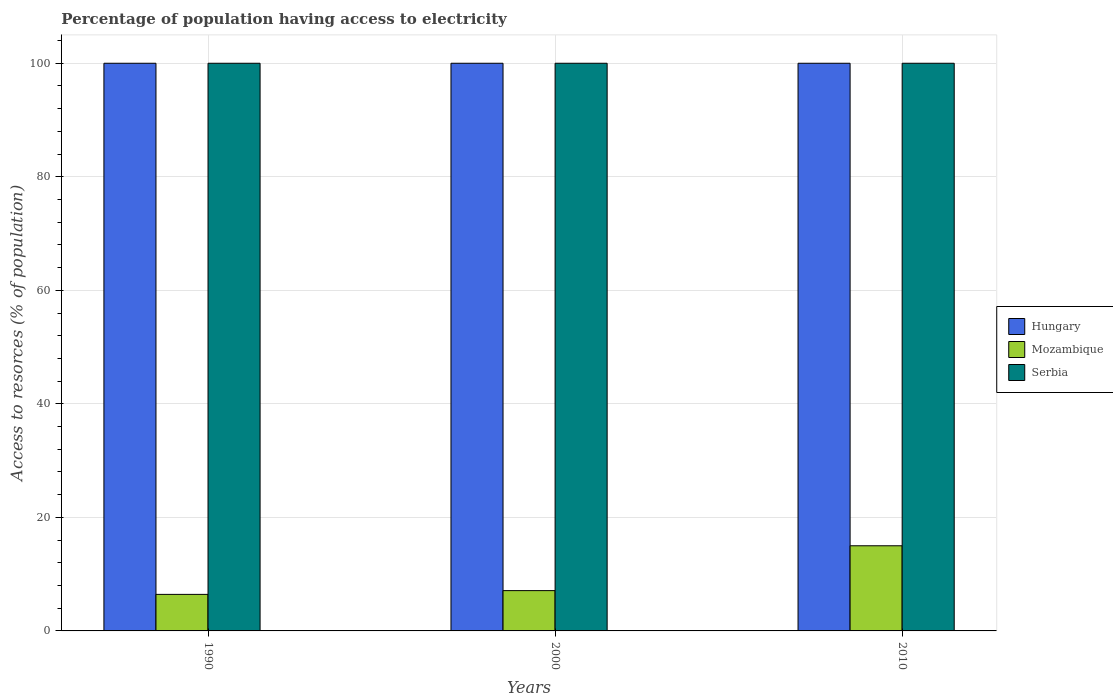Are the number of bars per tick equal to the number of legend labels?
Give a very brief answer. Yes. Are the number of bars on each tick of the X-axis equal?
Keep it short and to the point. Yes. How many bars are there on the 3rd tick from the left?
Make the answer very short. 3. Across all years, what is the maximum percentage of population having access to electricity in Hungary?
Give a very brief answer. 100. Across all years, what is the minimum percentage of population having access to electricity in Mozambique?
Your answer should be compact. 6.44. In which year was the percentage of population having access to electricity in Serbia maximum?
Keep it short and to the point. 1990. In which year was the percentage of population having access to electricity in Mozambique minimum?
Your response must be concise. 1990. What is the total percentage of population having access to electricity in Hungary in the graph?
Your response must be concise. 300. What is the difference between the percentage of population having access to electricity in Serbia in 2010 and the percentage of population having access to electricity in Hungary in 1990?
Your answer should be compact. 0. What is the average percentage of population having access to electricity in Mozambique per year?
Your response must be concise. 9.51. In the year 2000, what is the difference between the percentage of population having access to electricity in Hungary and percentage of population having access to electricity in Mozambique?
Provide a short and direct response. 92.9. In how many years, is the percentage of population having access to electricity in Serbia greater than 4 %?
Make the answer very short. 3. What is the ratio of the percentage of population having access to electricity in Hungary in 1990 to that in 2010?
Provide a succinct answer. 1. Is the difference between the percentage of population having access to electricity in Hungary in 2000 and 2010 greater than the difference between the percentage of population having access to electricity in Mozambique in 2000 and 2010?
Keep it short and to the point. Yes. What is the difference between the highest and the second highest percentage of population having access to electricity in Serbia?
Your answer should be compact. 0. What is the difference between the highest and the lowest percentage of population having access to electricity in Serbia?
Provide a succinct answer. 0. Is the sum of the percentage of population having access to electricity in Mozambique in 1990 and 2010 greater than the maximum percentage of population having access to electricity in Serbia across all years?
Your response must be concise. No. What does the 3rd bar from the left in 1990 represents?
Ensure brevity in your answer.  Serbia. What does the 2nd bar from the right in 1990 represents?
Your answer should be very brief. Mozambique. Is it the case that in every year, the sum of the percentage of population having access to electricity in Serbia and percentage of population having access to electricity in Hungary is greater than the percentage of population having access to electricity in Mozambique?
Ensure brevity in your answer.  Yes. Are the values on the major ticks of Y-axis written in scientific E-notation?
Ensure brevity in your answer.  No. Does the graph contain grids?
Keep it short and to the point. Yes. Where does the legend appear in the graph?
Keep it short and to the point. Center right. How are the legend labels stacked?
Provide a short and direct response. Vertical. What is the title of the graph?
Your answer should be very brief. Percentage of population having access to electricity. Does "Central African Republic" appear as one of the legend labels in the graph?
Your response must be concise. No. What is the label or title of the X-axis?
Your answer should be compact. Years. What is the label or title of the Y-axis?
Offer a very short reply. Access to resorces (% of population). What is the Access to resorces (% of population) in Mozambique in 1990?
Give a very brief answer. 6.44. What is the Access to resorces (% of population) in Serbia in 1990?
Ensure brevity in your answer.  100. What is the Access to resorces (% of population) in Hungary in 2000?
Provide a succinct answer. 100. What is the Access to resorces (% of population) of Mozambique in 2000?
Ensure brevity in your answer.  7.1. What is the Access to resorces (% of population) in Hungary in 2010?
Offer a terse response. 100. What is the Access to resorces (% of population) in Serbia in 2010?
Give a very brief answer. 100. Across all years, what is the maximum Access to resorces (% of population) of Mozambique?
Offer a terse response. 15. Across all years, what is the minimum Access to resorces (% of population) of Mozambique?
Offer a terse response. 6.44. Across all years, what is the minimum Access to resorces (% of population) in Serbia?
Give a very brief answer. 100. What is the total Access to resorces (% of population) of Hungary in the graph?
Provide a succinct answer. 300. What is the total Access to resorces (% of population) in Mozambique in the graph?
Keep it short and to the point. 28.54. What is the total Access to resorces (% of population) in Serbia in the graph?
Your answer should be very brief. 300. What is the difference between the Access to resorces (% of population) in Mozambique in 1990 and that in 2000?
Offer a very short reply. -0.66. What is the difference between the Access to resorces (% of population) in Hungary in 1990 and that in 2010?
Your response must be concise. 0. What is the difference between the Access to resorces (% of population) of Mozambique in 1990 and that in 2010?
Offer a very short reply. -8.56. What is the difference between the Access to resorces (% of population) in Serbia in 1990 and that in 2010?
Your answer should be compact. 0. What is the difference between the Access to resorces (% of population) in Hungary in 2000 and that in 2010?
Your answer should be very brief. 0. What is the difference between the Access to resorces (% of population) of Serbia in 2000 and that in 2010?
Offer a terse response. 0. What is the difference between the Access to resorces (% of population) of Hungary in 1990 and the Access to resorces (% of population) of Mozambique in 2000?
Your response must be concise. 92.9. What is the difference between the Access to resorces (% of population) in Hungary in 1990 and the Access to resorces (% of population) in Serbia in 2000?
Make the answer very short. 0. What is the difference between the Access to resorces (% of population) in Mozambique in 1990 and the Access to resorces (% of population) in Serbia in 2000?
Make the answer very short. -93.56. What is the difference between the Access to resorces (% of population) of Hungary in 1990 and the Access to resorces (% of population) of Mozambique in 2010?
Your answer should be compact. 85. What is the difference between the Access to resorces (% of population) of Mozambique in 1990 and the Access to resorces (% of population) of Serbia in 2010?
Give a very brief answer. -93.56. What is the difference between the Access to resorces (% of population) in Mozambique in 2000 and the Access to resorces (% of population) in Serbia in 2010?
Provide a short and direct response. -92.9. What is the average Access to resorces (% of population) in Hungary per year?
Keep it short and to the point. 100. What is the average Access to resorces (% of population) in Mozambique per year?
Your response must be concise. 9.51. What is the average Access to resorces (% of population) of Serbia per year?
Give a very brief answer. 100. In the year 1990, what is the difference between the Access to resorces (% of population) in Hungary and Access to resorces (% of population) in Mozambique?
Provide a short and direct response. 93.56. In the year 1990, what is the difference between the Access to resorces (% of population) of Hungary and Access to resorces (% of population) of Serbia?
Your response must be concise. 0. In the year 1990, what is the difference between the Access to resorces (% of population) of Mozambique and Access to resorces (% of population) of Serbia?
Keep it short and to the point. -93.56. In the year 2000, what is the difference between the Access to resorces (% of population) of Hungary and Access to resorces (% of population) of Mozambique?
Your answer should be very brief. 92.9. In the year 2000, what is the difference between the Access to resorces (% of population) in Hungary and Access to resorces (% of population) in Serbia?
Provide a succinct answer. 0. In the year 2000, what is the difference between the Access to resorces (% of population) in Mozambique and Access to resorces (% of population) in Serbia?
Give a very brief answer. -92.9. In the year 2010, what is the difference between the Access to resorces (% of population) of Hungary and Access to resorces (% of population) of Mozambique?
Make the answer very short. 85. In the year 2010, what is the difference between the Access to resorces (% of population) of Hungary and Access to resorces (% of population) of Serbia?
Provide a succinct answer. 0. In the year 2010, what is the difference between the Access to resorces (% of population) in Mozambique and Access to resorces (% of population) in Serbia?
Offer a terse response. -85. What is the ratio of the Access to resorces (% of population) of Hungary in 1990 to that in 2000?
Make the answer very short. 1. What is the ratio of the Access to resorces (% of population) in Mozambique in 1990 to that in 2000?
Your answer should be compact. 0.91. What is the ratio of the Access to resorces (% of population) in Serbia in 1990 to that in 2000?
Your answer should be compact. 1. What is the ratio of the Access to resorces (% of population) in Mozambique in 1990 to that in 2010?
Make the answer very short. 0.43. What is the ratio of the Access to resorces (% of population) of Serbia in 1990 to that in 2010?
Provide a short and direct response. 1. What is the ratio of the Access to resorces (% of population) in Mozambique in 2000 to that in 2010?
Offer a very short reply. 0.47. What is the ratio of the Access to resorces (% of population) of Serbia in 2000 to that in 2010?
Make the answer very short. 1. What is the difference between the highest and the second highest Access to resorces (% of population) of Hungary?
Provide a succinct answer. 0. What is the difference between the highest and the lowest Access to resorces (% of population) of Mozambique?
Offer a terse response. 8.56. What is the difference between the highest and the lowest Access to resorces (% of population) of Serbia?
Ensure brevity in your answer.  0. 